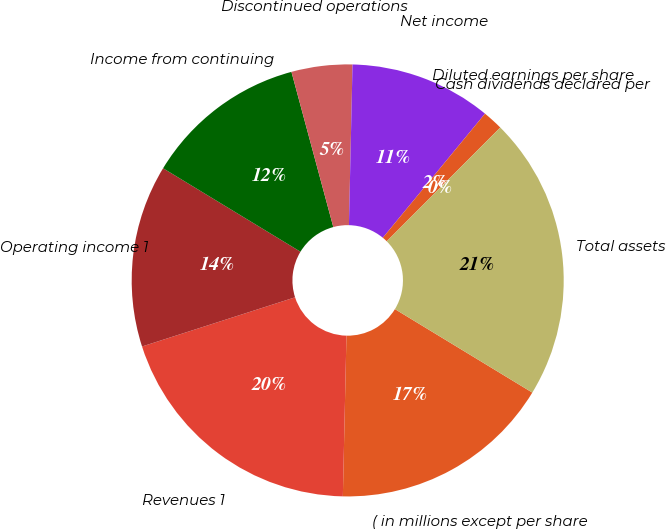Convert chart. <chart><loc_0><loc_0><loc_500><loc_500><pie_chart><fcel>( in millions except per share<fcel>Revenues 1<fcel>Operating income 1<fcel>Income from continuing<fcel>Discontinued operations<fcel>Net income<fcel>Diluted earnings per share<fcel>Cash dividends declared per<fcel>Total assets<nl><fcel>16.67%<fcel>19.7%<fcel>13.64%<fcel>12.12%<fcel>4.55%<fcel>10.61%<fcel>1.52%<fcel>0.0%<fcel>21.21%<nl></chart> 